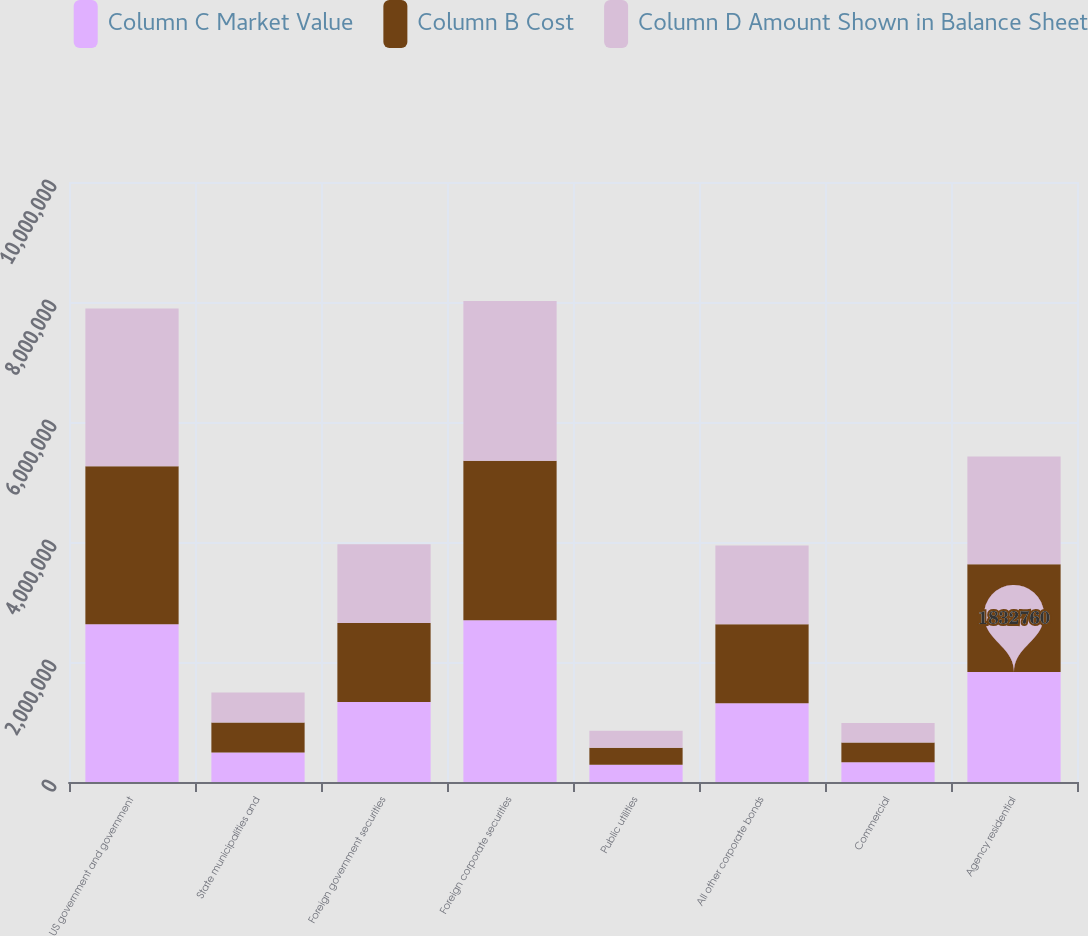<chart> <loc_0><loc_0><loc_500><loc_500><stacked_bar_chart><ecel><fcel>US government and government<fcel>State municipalities and<fcel>Foreign government securities<fcel>Foreign corporate securities<fcel>Public utilities<fcel>All other corporate bonds<fcel>Commercial<fcel>Agency residential<nl><fcel>Column C Market Value<fcel>2.62945e+06<fcel>490018<fcel>1.33533e+06<fcel>2.69492e+06<fcel>287784<fcel>1.31416e+06<fcel>329883<fcel>1.83276e+06<nl><fcel>Column B Cost<fcel>2.63113e+06<fcel>500094<fcel>1.31416e+06<fcel>2.66106e+06<fcel>283903<fcel>1.31416e+06<fcel>326710<fcel>1.79626e+06<nl><fcel>Column D Amount Shown in Balance Sheet<fcel>2.63113e+06<fcel>500094<fcel>1.31416e+06<fcel>2.66106e+06<fcel>283903<fcel>1.31416e+06<fcel>326710<fcel>1.79626e+06<nl></chart> 